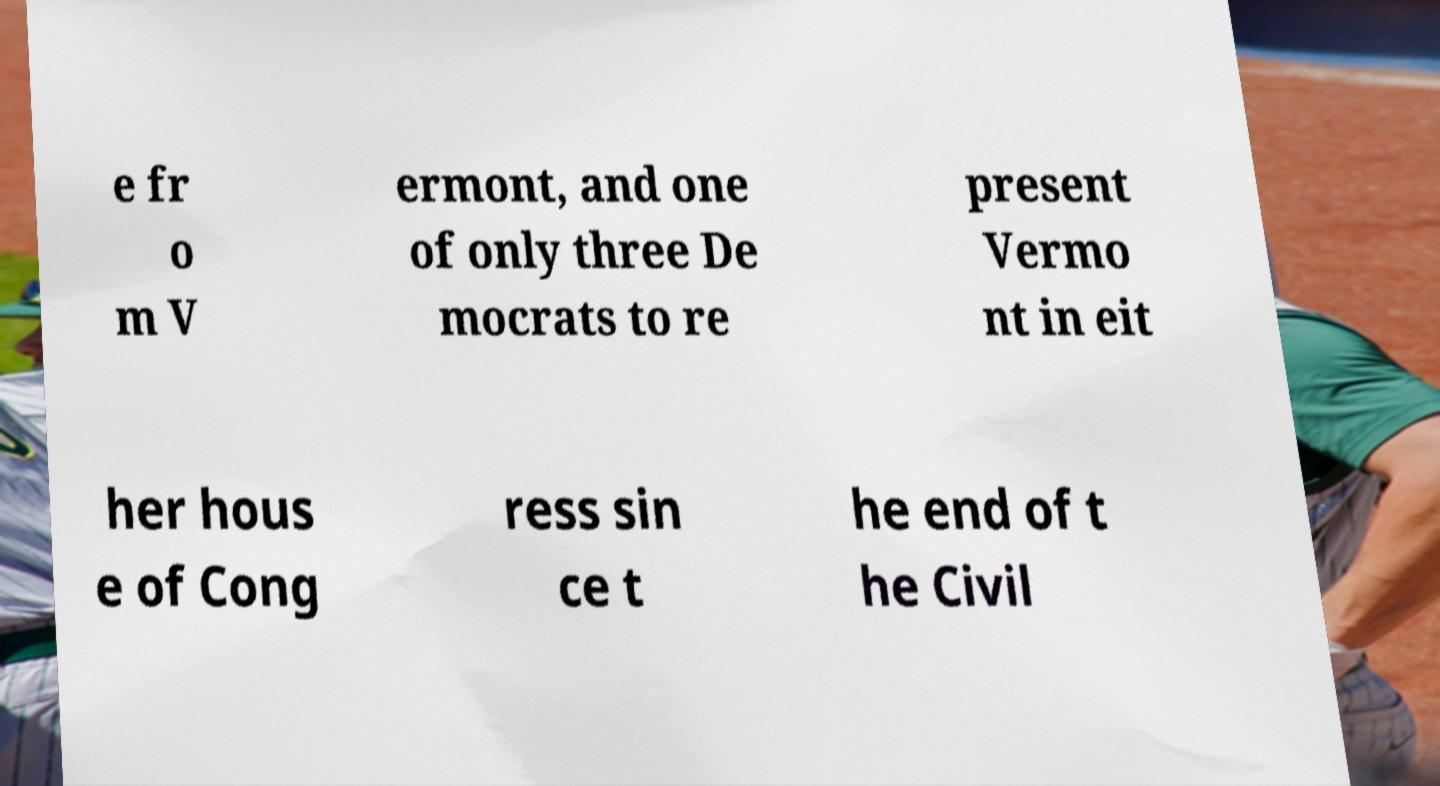Could you extract and type out the text from this image? e fr o m V ermont, and one of only three De mocrats to re present Vermo nt in eit her hous e of Cong ress sin ce t he end of t he Civil 